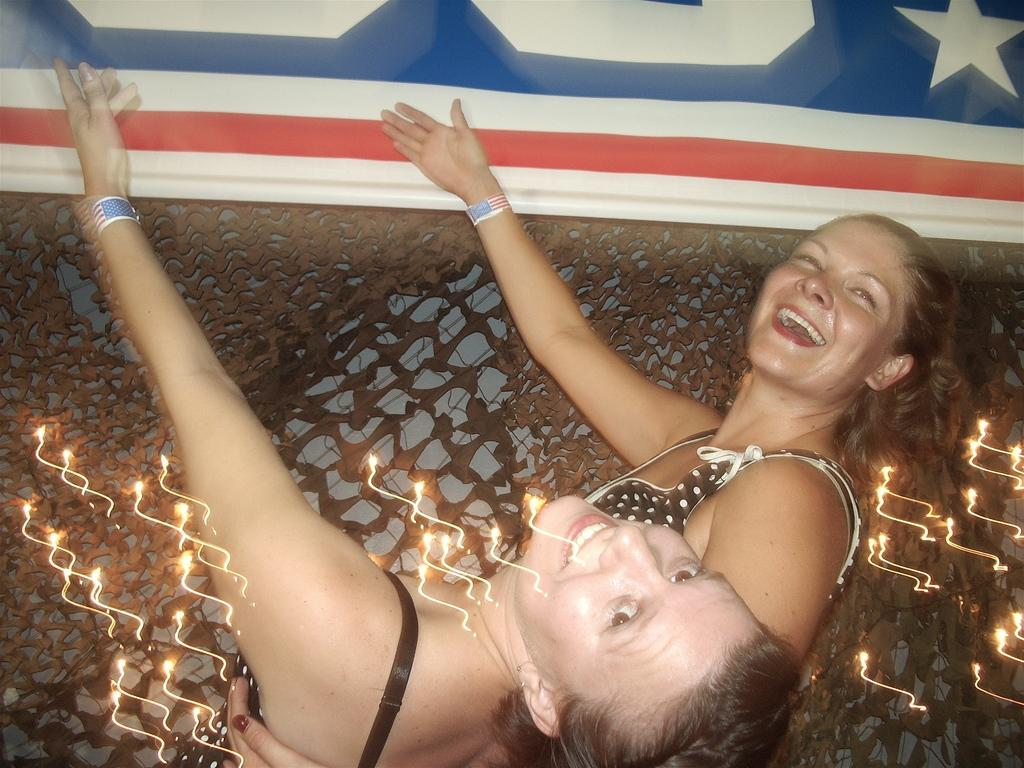How many people are in the image? There are two persons in the image. What is the facial expression of the persons in the image? The persons are smiling. Can you describe any objects present in the image? Unfortunately, the provided facts do not specify any objects in the image. What color is the scarf worn by the ant in the image? There is no ant or scarf present in the image. What type of pot is visible in the image? There is no pot present in the image. 